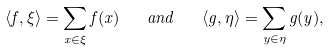<formula> <loc_0><loc_0><loc_500><loc_500>\langle f , \xi \rangle = \sum _ { x \in \xi } f ( x ) \quad a n d \quad \langle g , \eta \rangle = \sum _ { y \in \eta } g ( y ) ,</formula> 